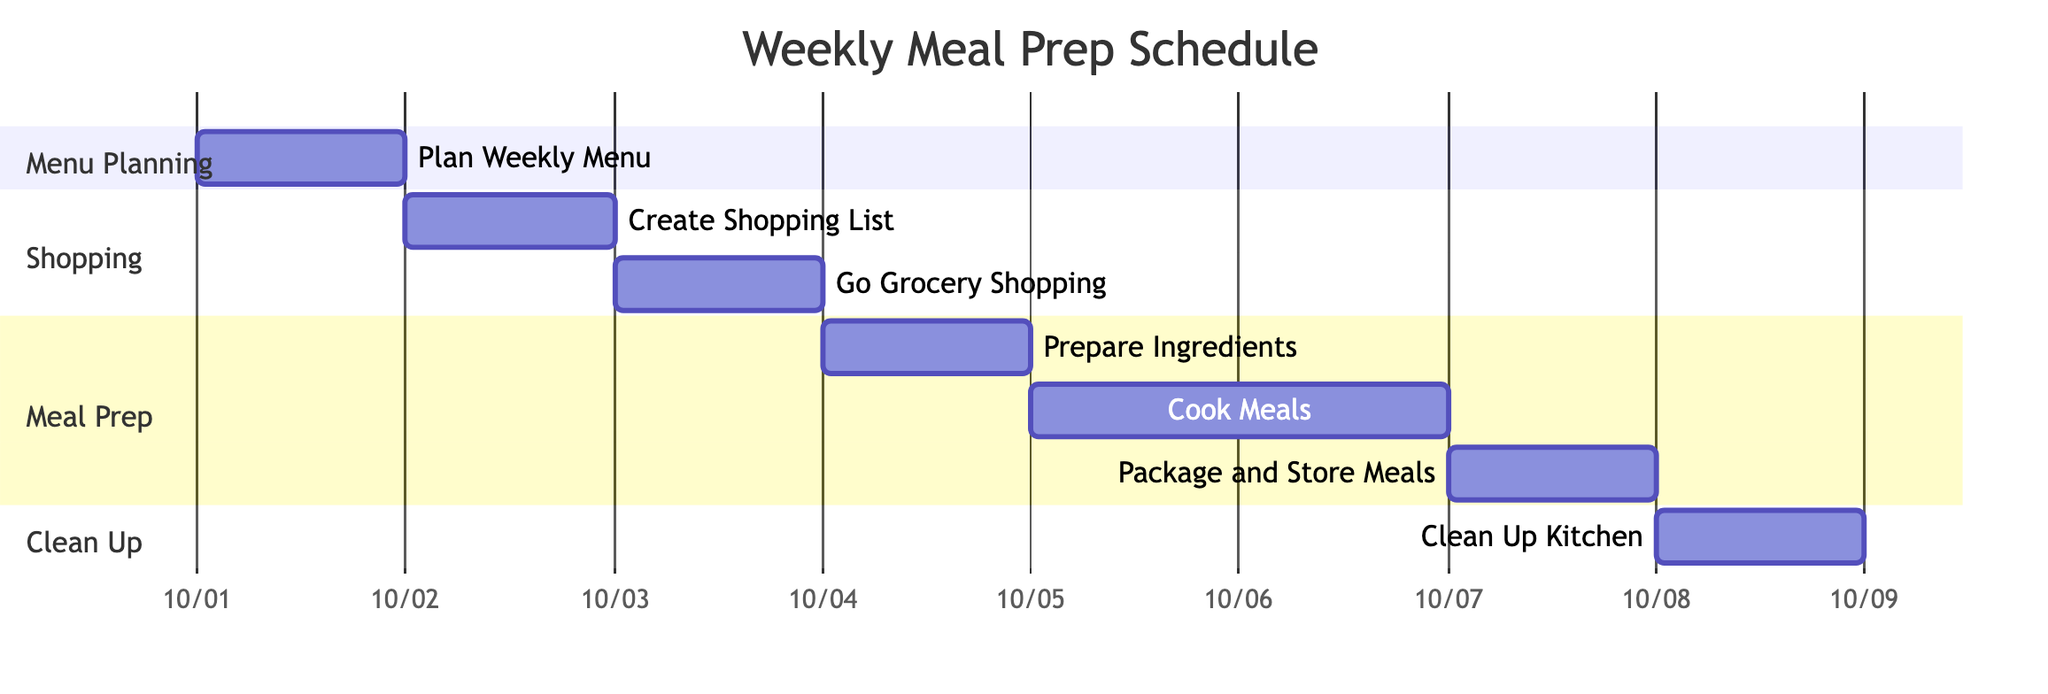What is the first task in the schedule? The diagram shows "Plan Weekly Menu" as the first task scheduled for October 1, 2023, clearly placed at the beginning of the timeline.
Answer: Plan Weekly Menu How many days does it take to cook meals? Referring to the "Cook Meals" task, it spans across 2 days, as indicated by the duration labeled next to it in the diagram.
Answer: 2 days What day is designated for grocery shopping? The "Go Grocery Shopping" task is marked for October 3, 2023, shown distinctly within the shopping section of the Gantt chart.
Answer: October 3, 2023 Which task follows packaging and storing meals? The "Clean Up Kitchen" task directly follows "Package and Store Meals," which is indicated by the sequential arrangement of tasks in the diagram.
Answer: Clean Up Kitchen How many tasks are scheduled after creating the shopping list? Counting from "Prepare Ingredients" to "Clean Up Kitchen," there are 4 tasks that follow "Create Shopping List" in the timeline, as they are all listed under respective sections below it.
Answer: 4 tasks What is the overall duration of the meal prep schedule? By identifying the start task on October 1 and the last task on October 8, the entire schedule lasts for 8 days in total, as depicted in the timeline.
Answer: 8 days What are the three main sections in the diagram? The diagram is divided into three main sections: "Menu Planning," "Shopping," "Meal Prep," and "Clean Up," each clearly labeled within their respective areas of the chart.
Answer: Menu Planning, Shopping, Meal Prep, Clean Up Which task has the longest duration? The task "Cook Meals" spans 2 days, which is longer than all other individual tasks, thereby making it the one with the longest duration in the entire schedule.
Answer: Cook Meals 